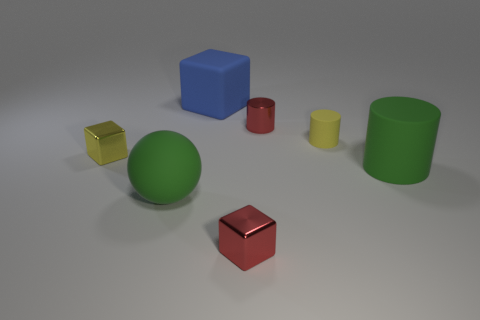Are any blue cubes visible?
Provide a succinct answer. Yes. How many other things are the same size as the blue matte cube?
Keep it short and to the point. 2. Do the ball and the small thing that is left of the blue object have the same material?
Keep it short and to the point. No. Are there an equal number of blue matte things that are right of the large cylinder and cylinders on the left side of the blue object?
Provide a succinct answer. Yes. What is the green cylinder made of?
Offer a very short reply. Rubber. What is the color of the rubber sphere that is the same size as the blue rubber block?
Provide a short and direct response. Green. There is a large green rubber thing that is behind the large green rubber ball; are there any small yellow cubes right of it?
Give a very brief answer. No. What number of blocks are small brown rubber things or tiny metallic objects?
Offer a terse response. 2. There is a yellow object left of the cylinder that is to the left of the rubber cylinder behind the big green matte cylinder; what is its size?
Offer a very short reply. Small. Are there any green rubber cylinders in front of the red metallic cube?
Give a very brief answer. No. 